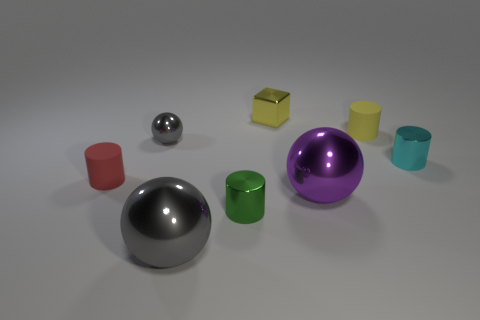What is the size of the object that is the same color as the tiny block?
Give a very brief answer. Small. The green thing in front of the big purple shiny sphere that is on the left side of the small rubber cylinder that is on the right side of the small green object is what shape?
Your answer should be very brief. Cylinder. There is a yellow thing that is on the right side of the big purple object; what material is it?
Your answer should be very brief. Rubber. There is a metallic block that is the same size as the cyan object; what is its color?
Offer a very short reply. Yellow. How many other objects are there of the same shape as the small yellow metal object?
Make the answer very short. 0. Do the green metallic thing and the red rubber cylinder have the same size?
Provide a short and direct response. Yes. Is the number of shiny cylinders to the left of the red rubber cylinder greater than the number of tiny cubes in front of the small green metallic thing?
Give a very brief answer. No. What number of other things are there of the same size as the red cylinder?
Your answer should be very brief. 5. There is a large sphere to the right of the block; is it the same color as the tiny block?
Ensure brevity in your answer.  No. Are there more small matte cylinders that are behind the tiny green shiny object than blocks?
Offer a very short reply. Yes. 